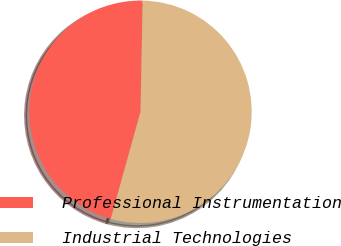<chart> <loc_0><loc_0><loc_500><loc_500><pie_chart><fcel>Professional Instrumentation<fcel>Industrial Technologies<nl><fcel>46.0%<fcel>54.0%<nl></chart> 